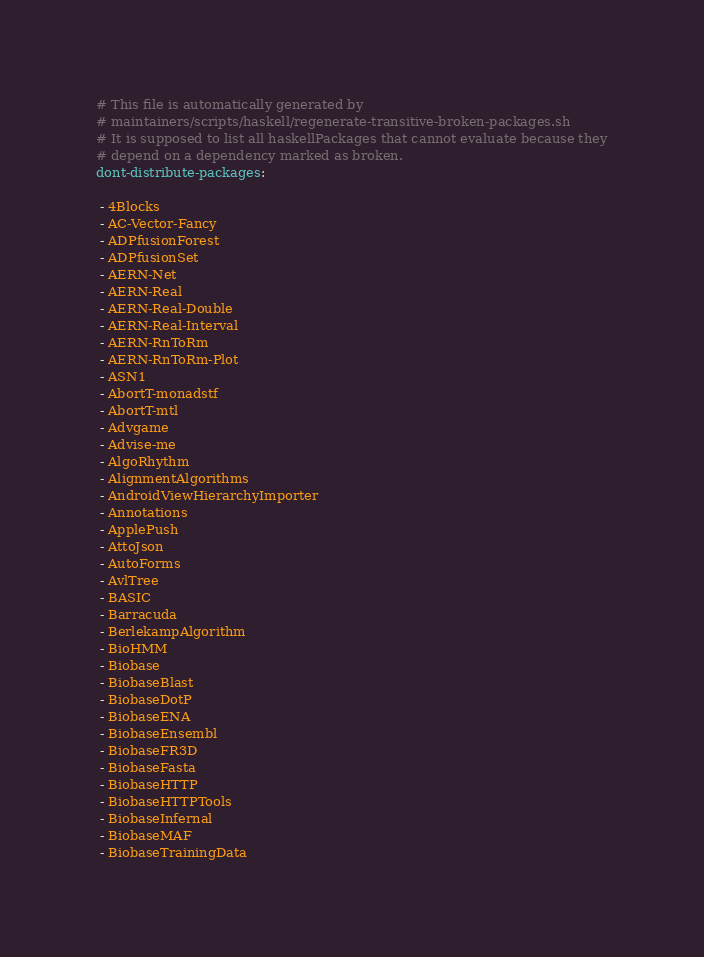Convert code to text. <code><loc_0><loc_0><loc_500><loc_500><_YAML_># This file is automatically generated by
# maintainers/scripts/haskell/regenerate-transitive-broken-packages.sh
# It is supposed to list all haskellPackages that cannot evaluate because they
# depend on a dependency marked as broken.
dont-distribute-packages:

 - 4Blocks
 - AC-Vector-Fancy
 - ADPfusionForest
 - ADPfusionSet
 - AERN-Net
 - AERN-Real
 - AERN-Real-Double
 - AERN-Real-Interval
 - AERN-RnToRm
 - AERN-RnToRm-Plot
 - ASN1
 - AbortT-monadstf
 - AbortT-mtl
 - Advgame
 - Advise-me
 - AlgoRhythm
 - AlignmentAlgorithms
 - AndroidViewHierarchyImporter
 - Annotations
 - ApplePush
 - AttoJson
 - AutoForms
 - AvlTree
 - BASIC
 - Barracuda
 - BerlekampAlgorithm
 - BioHMM
 - Biobase
 - BiobaseBlast
 - BiobaseDotP
 - BiobaseENA
 - BiobaseEnsembl
 - BiobaseFR3D
 - BiobaseFasta
 - BiobaseHTTP
 - BiobaseHTTPTools
 - BiobaseInfernal
 - BiobaseMAF
 - BiobaseTrainingData</code> 